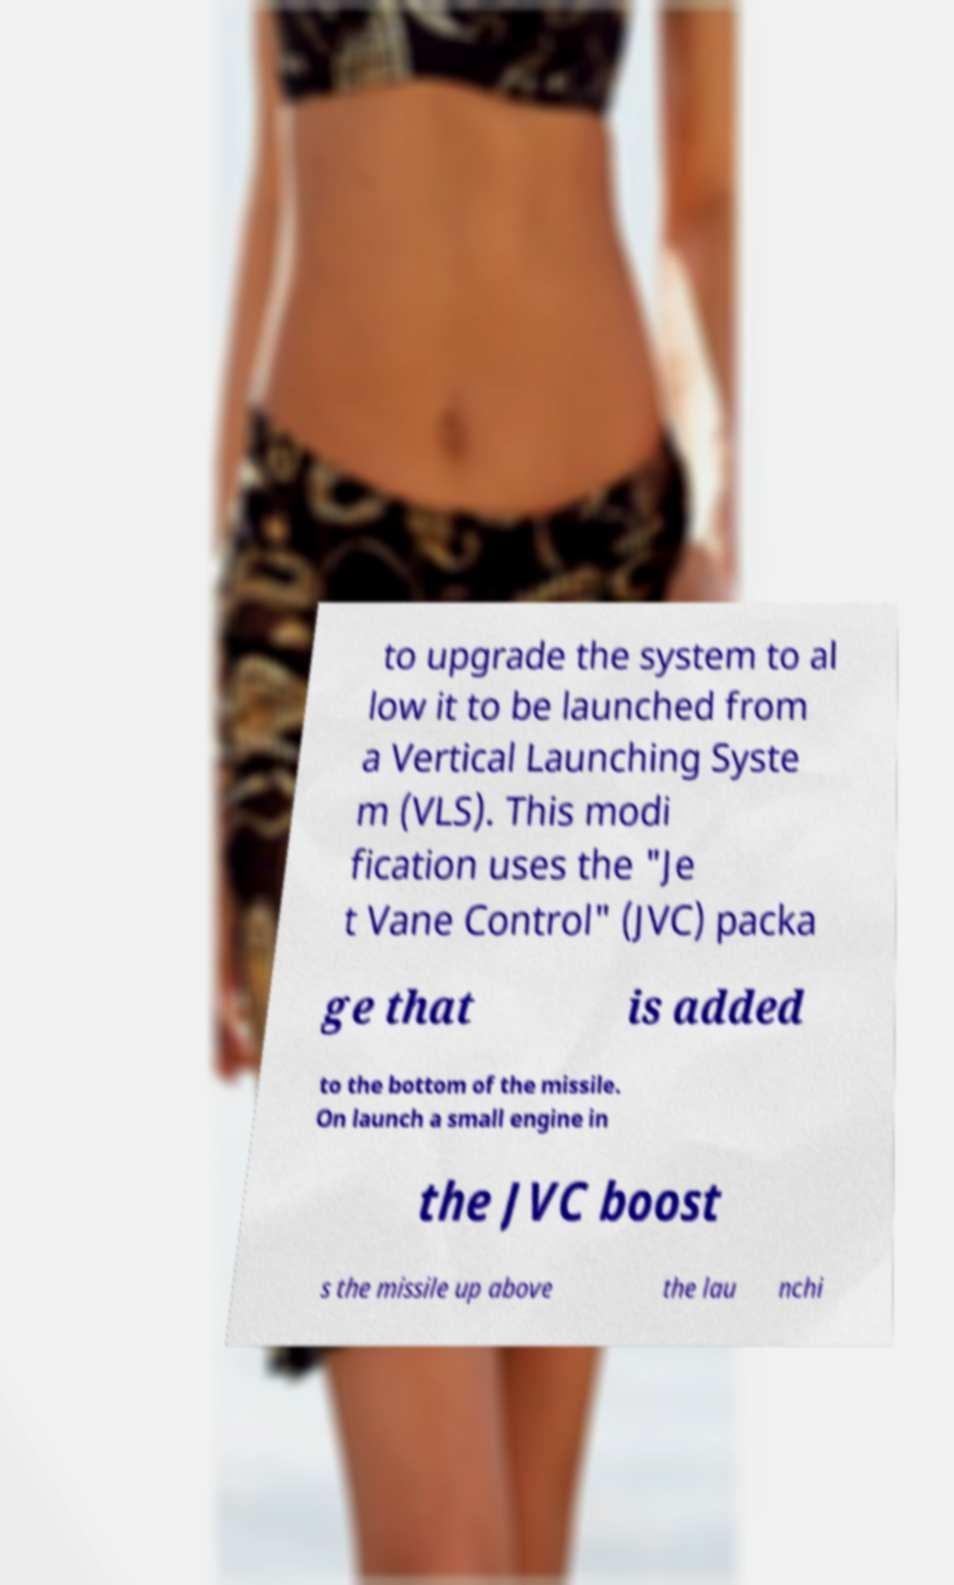For documentation purposes, I need the text within this image transcribed. Could you provide that? to upgrade the system to al low it to be launched from a Vertical Launching Syste m (VLS). This modi fication uses the "Je t Vane Control" (JVC) packa ge that is added to the bottom of the missile. On launch a small engine in the JVC boost s the missile up above the lau nchi 